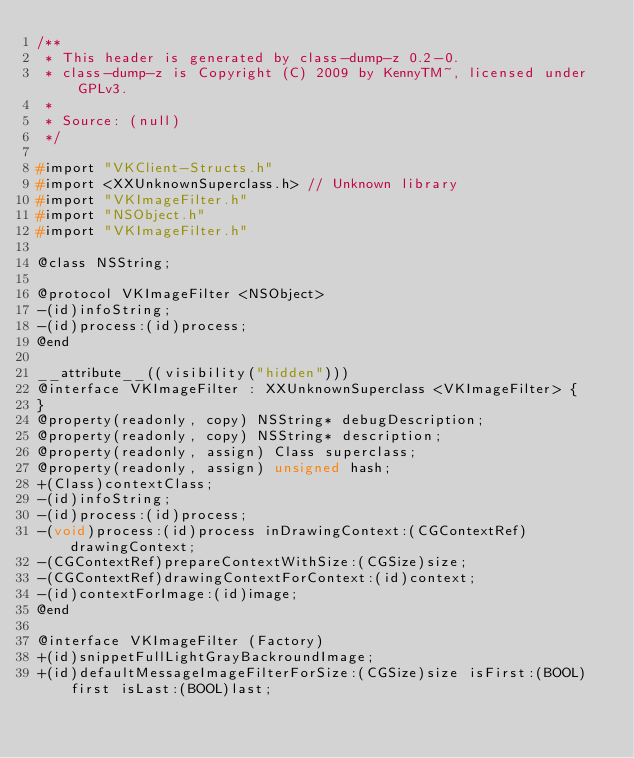<code> <loc_0><loc_0><loc_500><loc_500><_C_>/**
 * This header is generated by class-dump-z 0.2-0.
 * class-dump-z is Copyright (C) 2009 by KennyTM~, licensed under GPLv3.
 *
 * Source: (null)
 */

#import "VKClient-Structs.h"
#import <XXUnknownSuperclass.h> // Unknown library
#import "VKImageFilter.h"
#import "NSObject.h"
#import "VKImageFilter.h"

@class NSString;

@protocol VKImageFilter <NSObject>
-(id)infoString;
-(id)process:(id)process;
@end

__attribute__((visibility("hidden")))
@interface VKImageFilter : XXUnknownSuperclass <VKImageFilter> {
}
@property(readonly, copy) NSString* debugDescription;
@property(readonly, copy) NSString* description;
@property(readonly, assign) Class superclass;
@property(readonly, assign) unsigned hash;
+(Class)contextClass;
-(id)infoString;
-(id)process:(id)process;
-(void)process:(id)process inDrawingContext:(CGContextRef)drawingContext;
-(CGContextRef)prepareContextWithSize:(CGSize)size;
-(CGContextRef)drawingContextForContext:(id)context;
-(id)contextForImage:(id)image;
@end

@interface VKImageFilter (Factory)
+(id)snippetFullLightGrayBackroundImage;
+(id)defaultMessageImageFilterForSize:(CGSize)size isFirst:(BOOL)first isLast:(BOOL)last;</code> 